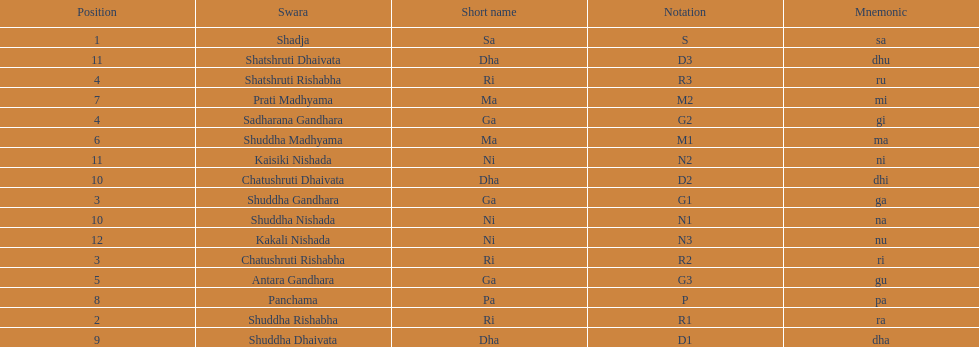Which swara holds the last position? Kakali Nishada. 